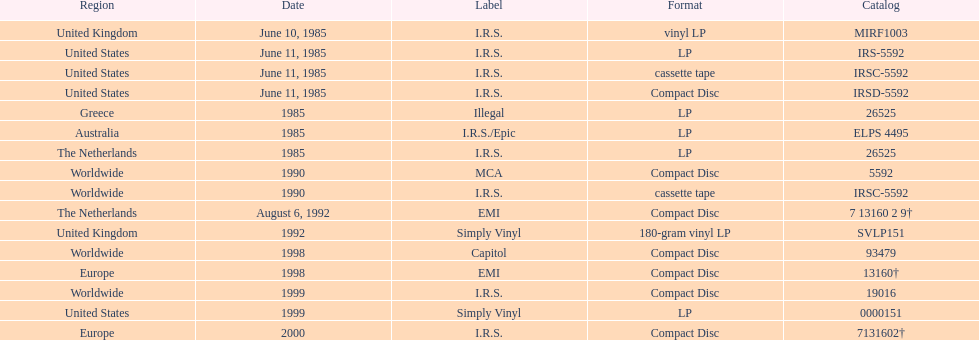What is the highest continuous number of releases in lp format? 3. 